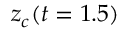<formula> <loc_0><loc_0><loc_500><loc_500>z _ { c } ( t = 1 . 5 )</formula> 